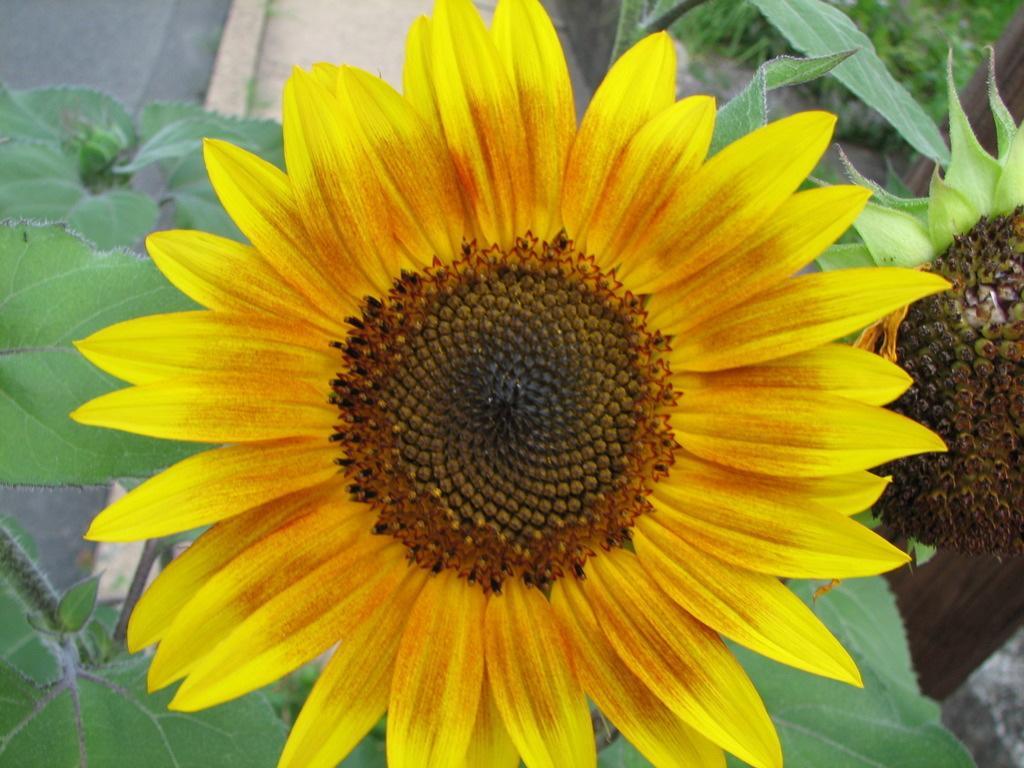Please provide a concise description of this image. In the center of the image there is a sunflower on a plant. In the background there is a road. 